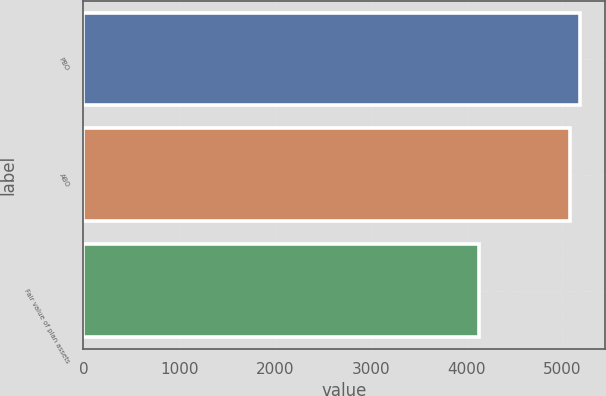Convert chart to OTSL. <chart><loc_0><loc_0><loc_500><loc_500><bar_chart><fcel>PBO<fcel>ABO<fcel>Fair value of plan assets<nl><fcel>5187<fcel>5076<fcel>4135<nl></chart> 